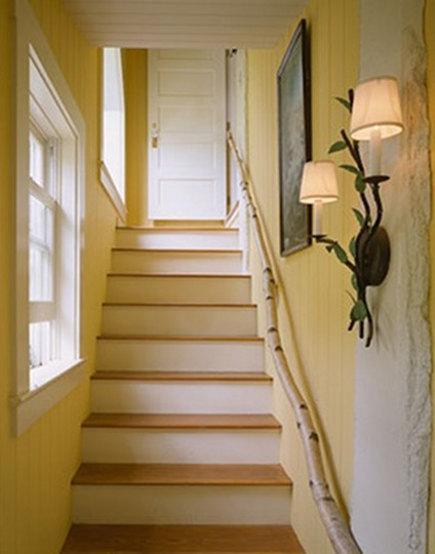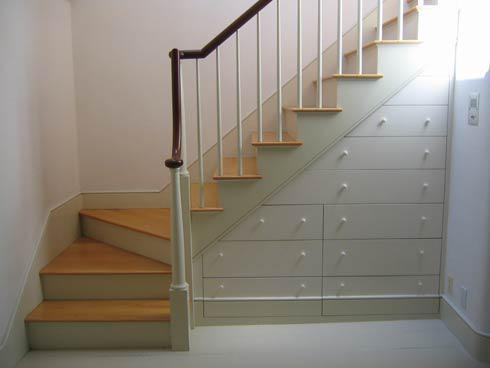The first image is the image on the left, the second image is the image on the right. Analyze the images presented: Is the assertion "One of the stair rails looks like a single branch from a tree." valid? Answer yes or no. Yes. The first image is the image on the left, the second image is the image on the right. Given the left and right images, does the statement "In the left image, a tree shape with a trunk at the base of the staircase has branches forming the railing as the stairs ascend rightward." hold true? Answer yes or no. No. 